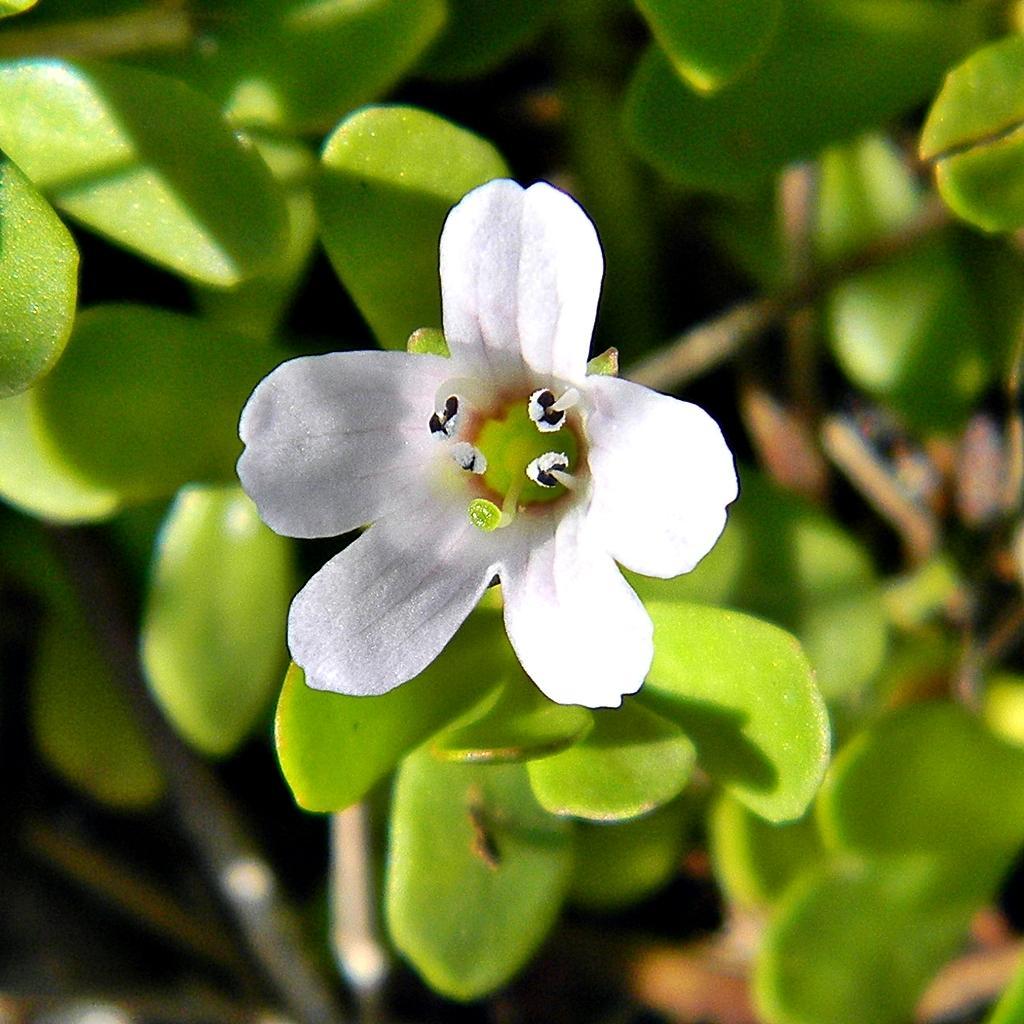Can you describe this image briefly? In the center of the image we can see a flower which is in white color. At the bottom there are plants. 